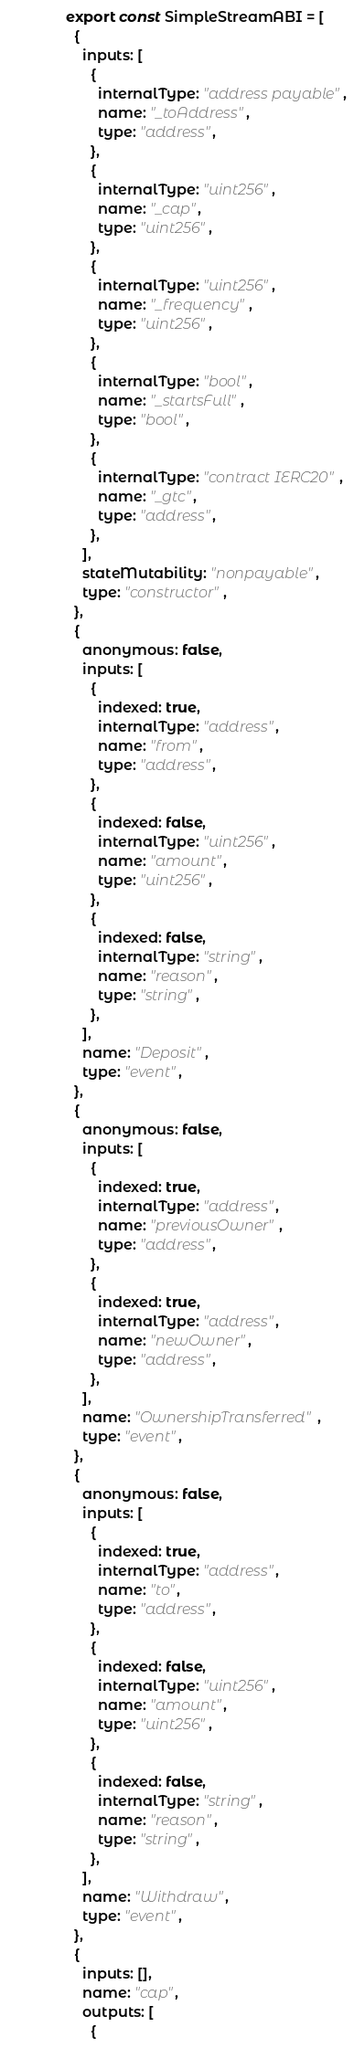Convert code to text. <code><loc_0><loc_0><loc_500><loc_500><_JavaScript_>export const SimpleStreamABI = [
  {
    inputs: [
      {
        internalType: "address payable",
        name: "_toAddress",
        type: "address",
      },
      {
        internalType: "uint256",
        name: "_cap",
        type: "uint256",
      },
      {
        internalType: "uint256",
        name: "_frequency",
        type: "uint256",
      },
      {
        internalType: "bool",
        name: "_startsFull",
        type: "bool",
      },
      {
        internalType: "contract IERC20",
        name: "_gtc",
        type: "address",
      },
    ],
    stateMutability: "nonpayable",
    type: "constructor",
  },
  {
    anonymous: false,
    inputs: [
      {
        indexed: true,
        internalType: "address",
        name: "from",
        type: "address",
      },
      {
        indexed: false,
        internalType: "uint256",
        name: "amount",
        type: "uint256",
      },
      {
        indexed: false,
        internalType: "string",
        name: "reason",
        type: "string",
      },
    ],
    name: "Deposit",
    type: "event",
  },
  {
    anonymous: false,
    inputs: [
      {
        indexed: true,
        internalType: "address",
        name: "previousOwner",
        type: "address",
      },
      {
        indexed: true,
        internalType: "address",
        name: "newOwner",
        type: "address",
      },
    ],
    name: "OwnershipTransferred",
    type: "event",
  },
  {
    anonymous: false,
    inputs: [
      {
        indexed: true,
        internalType: "address",
        name: "to",
        type: "address",
      },
      {
        indexed: false,
        internalType: "uint256",
        name: "amount",
        type: "uint256",
      },
      {
        indexed: false,
        internalType: "string",
        name: "reason",
        type: "string",
      },
    ],
    name: "Withdraw",
    type: "event",
  },
  {
    inputs: [],
    name: "cap",
    outputs: [
      {</code> 